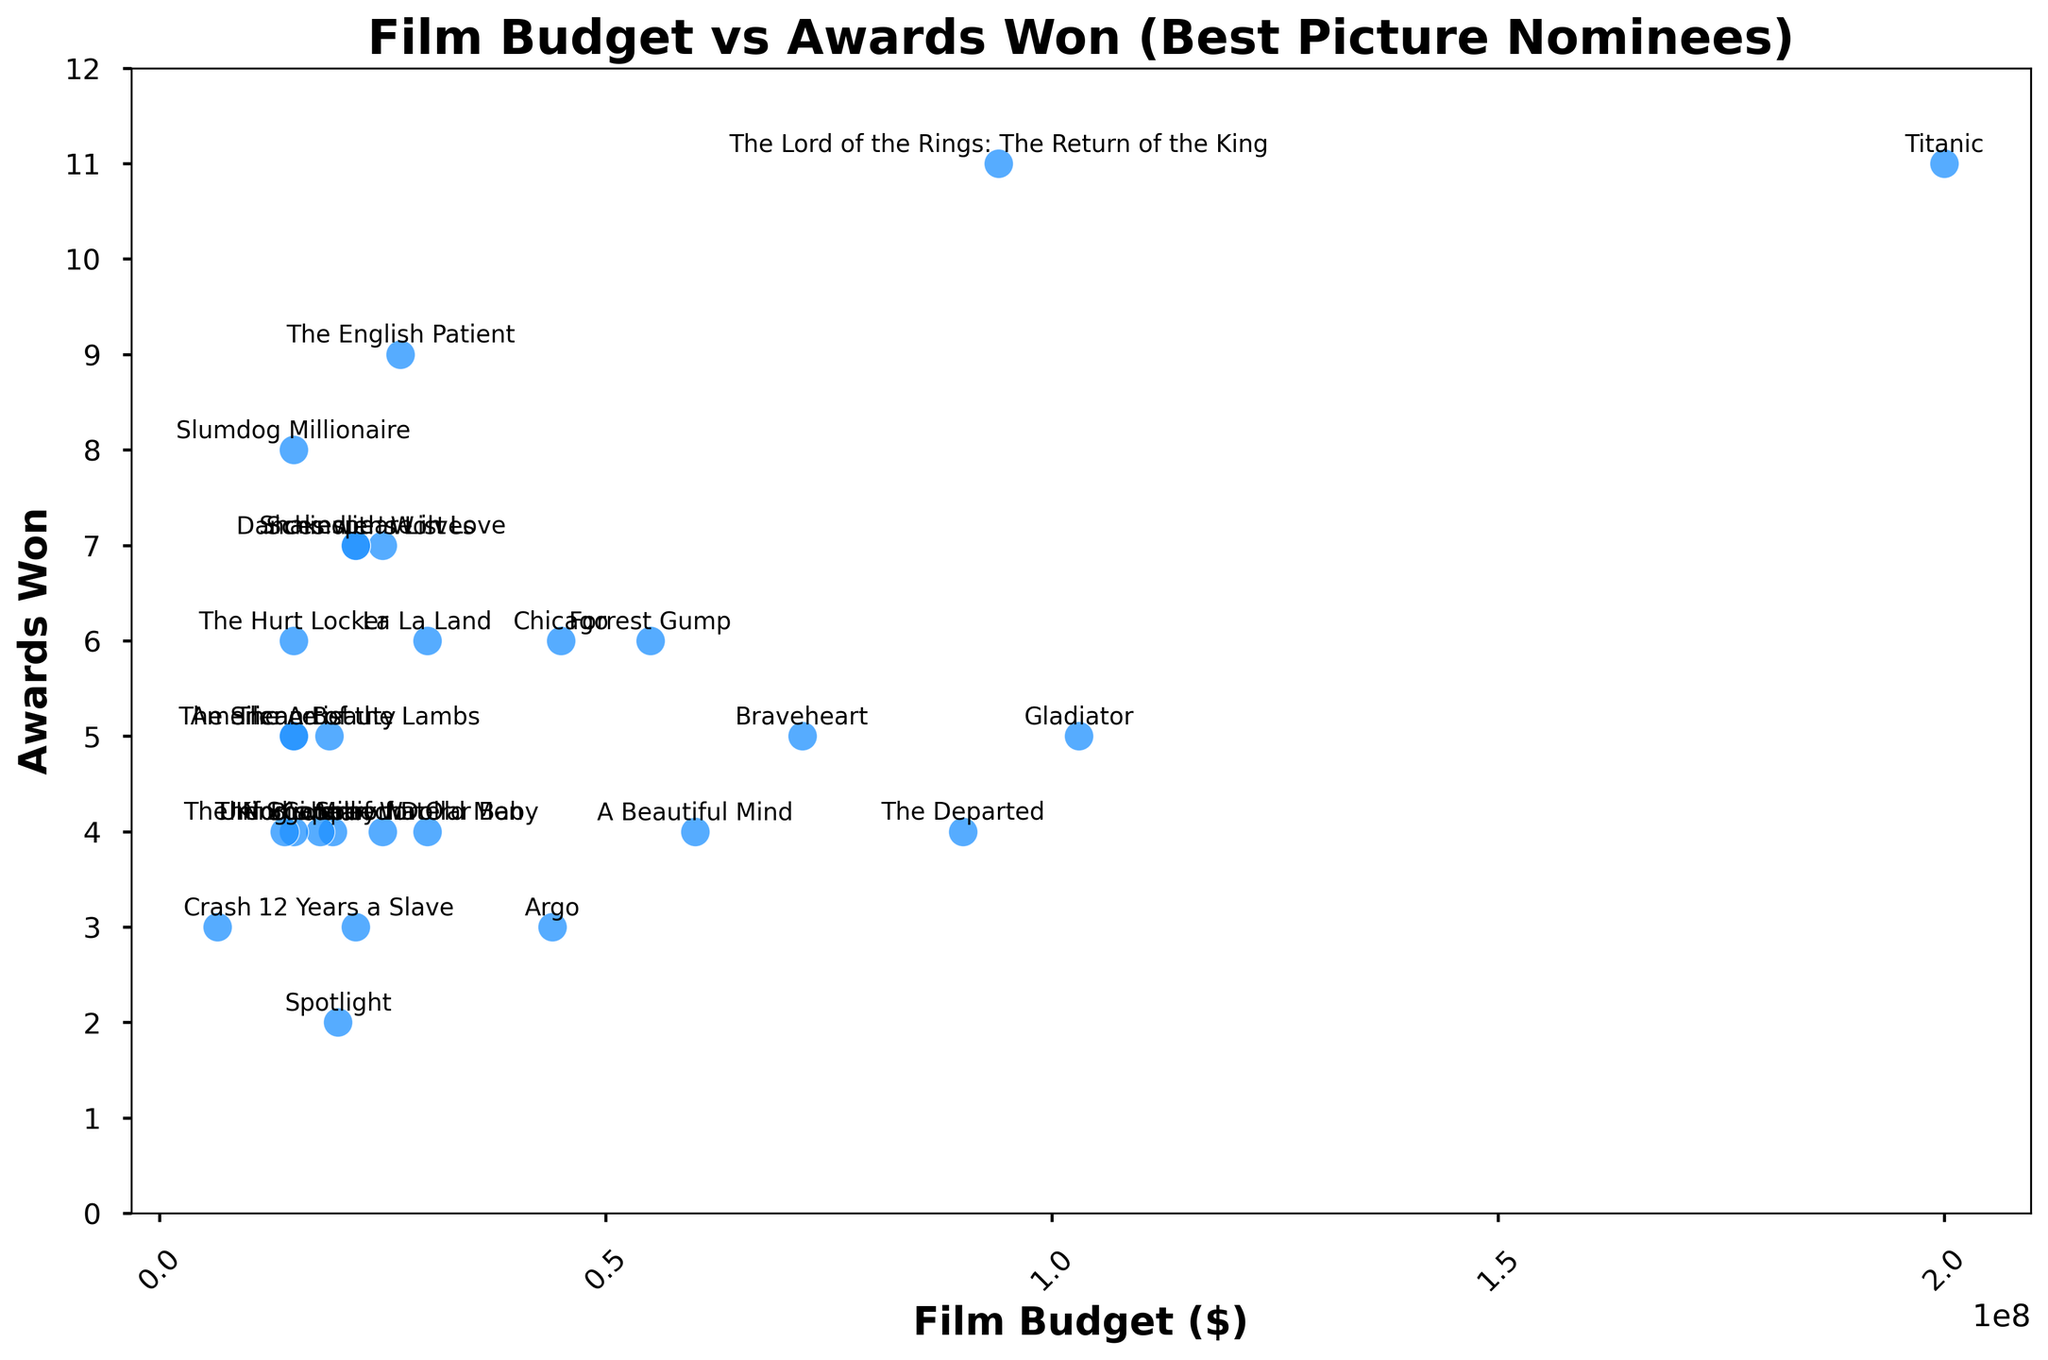Is there any noticeable correlation between film budgets and the number of awards won? The scatter plot shows multiple points each representing a film's budget and the corresponding number of awards it won. A notable pattern or trend between these two variables indicates correlation. Upon examining the points, we see that both high-budget films like "Titanic" and low-budget films like "Crash" have won multiple awards, suggesting little to no clear correlation.
Answer: No clear correlation Which film had the highest budget, and how many awards did it win? By looking at the point on the scatter plot with the furthest placement along the x-axis (highest budget), we see that "Titanic" had the highest budget of $200,000,000 and it won 11 awards.
Answer: Titanic with 11 awards What is the budget range of films that won exactly 4 awards? We identify all the points that have exactly 4 awards on the y-axis. These films include "The Shape of Water", "Birdman", "The King's Speech", "Million Dollar Baby", "Unforgiven", "The Departed", and "A Beautiful Mind". Checking their budgets: $19.4M, $18M, $15M, $30M, $14M, $90M, and $60M respectively. The range is from $14M to $90M.
Answer: $14M to $90M Which film won the most awards, and how does its budget compare to those of the other films? In the scatter plot, the point highest along the y-axis corresponds to the most awards. "The Lord of the Rings: The Return of the King" won the most awards (11). Its budget of $94M is relatively high but not the highest compared to other films with substantial budgets, e.g., "Titanic" and "Gladiator".
Answer: The Lord of the Rings: The Return of the King, budget is high but not the highest Compare the average budget of films that won over 5 awards to those that won 5 or fewer awards. First, identify and list budgets of films in both groups. Over 5 awards: "La La Land" ($30M), "The Hurt Locker" ($15M), "Slumdog Millionaire" ($15M), "The English Patient" ($27M), "Titanic" ($200M), "Shakespeare in Love" ($25M). Over 5 Awards Average: ($30M + $15M + $15M + $27M + $200M + $25M)/6 = $52M. 5 or fewer awards: Calculate average of remaining films (a similar listing and arithmetic summation process).
Answer: $52M for over 5 awards Which films had budgets lower than $20M but won more than 3 awards? Locate the points which lie below $20M on the x-axis and above 3 awards on the y-axis. The films fitting this description are "The Shape of Water" ($19.4M, 4 awards), "Birdman" ($18M, 4 awards), "The King's Speech" ($15M, 4 awards), "The Hurt Locker" ($15M, 6 awards), "Crash" ($6.5M, 3 awards), and "The Silence of the Lambs" ($19M, 5 awards).
Answer: The Shape of Water, Birdman, The King's Speech, The Hurt Locker, The Silence of the Lambs What is the median budget of the films shown in the scatter plot? First, list all film budgets in ascending order. Then, find the middle value (or the average of the two middle values, if the list length is even). With 28 films, the median is the average of the 14th and 15th values in the sorted list. Sorted Budgets: $6.5M, $14M, $15M, $15M, $15M, $15M, $15M, $18M, $19M, $19.4M, $20M, $22M, $22M, $22M, $25M, $25M, $27M, $30M, $30M, $44M, $45M, $55M, $60M, $72M, $90M, $94M, $103M, $200M. 14th and 15th values: both $22M, so median is $22M.
Answer: $22M 